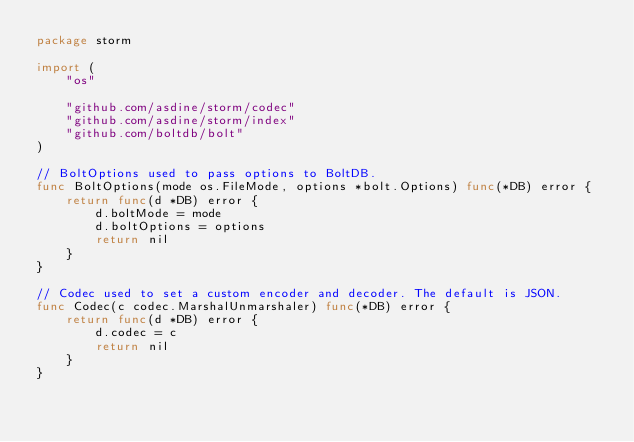<code> <loc_0><loc_0><loc_500><loc_500><_Go_>package storm

import (
	"os"

	"github.com/asdine/storm/codec"
	"github.com/asdine/storm/index"
	"github.com/boltdb/bolt"
)

// BoltOptions used to pass options to BoltDB.
func BoltOptions(mode os.FileMode, options *bolt.Options) func(*DB) error {
	return func(d *DB) error {
		d.boltMode = mode
		d.boltOptions = options
		return nil
	}
}

// Codec used to set a custom encoder and decoder. The default is JSON.
func Codec(c codec.MarshalUnmarshaler) func(*DB) error {
	return func(d *DB) error {
		d.codec = c
		return nil
	}
}
</code> 